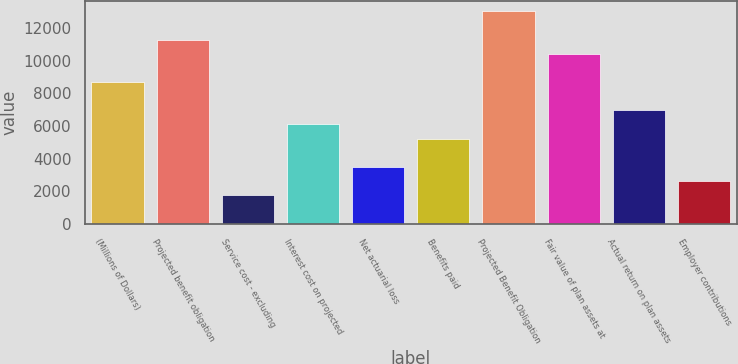Convert chart to OTSL. <chart><loc_0><loc_0><loc_500><loc_500><bar_chart><fcel>(Millions of Dollars)<fcel>Projected benefit obligation<fcel>Service cost - excluding<fcel>Interest cost on projected<fcel>Net actuarial loss<fcel>Benefits paid<fcel>Projected Benefit Obligation<fcel>Fair value of plan assets at<fcel>Actual return on plan assets<fcel>Employer contributions<nl><fcel>8696<fcel>11295.8<fcel>1763.2<fcel>6096.2<fcel>3496.4<fcel>5229.6<fcel>13029<fcel>10429.2<fcel>6962.8<fcel>2629.8<nl></chart> 